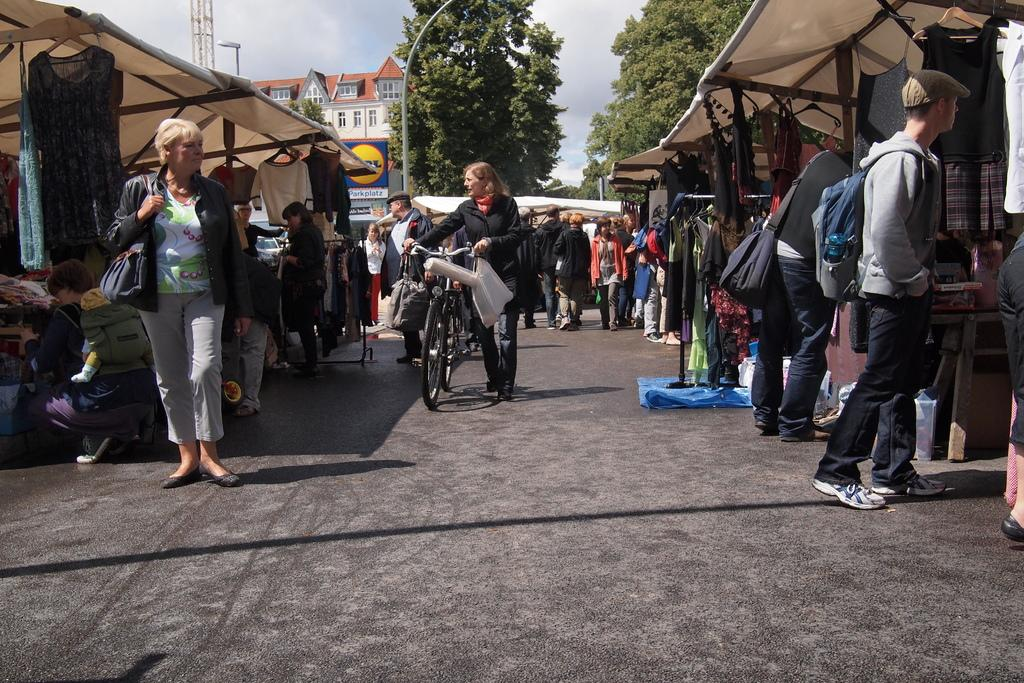What is happening on the road in the image? There are persons on the road in the image. What is the woman doing in the image? A woman is holding a bicycle in the image. What type of structures can be seen in the image? There are stalls in the image, and a building is visible in the background. What can be seen in the background of the image? A hoarding, poles, trees, and the sky are visible in the background. What type of tin is being used as a reward for the judge in the image? There is no tin, reward, or judge present in the image. 